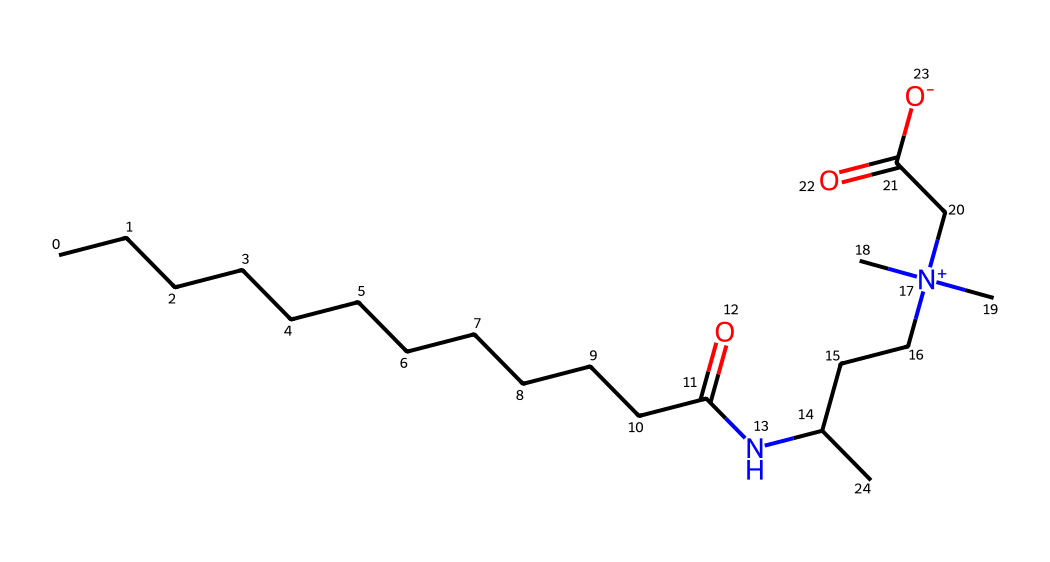What is the name of this chemical? The SMILES representation identifies this chemical as cocamidopropyl betaine, which is a common surfactant.
Answer: cocamidopropyl betaine How many carbon atoms are present in this structure? By analyzing the SMILES, there are twelve carbon atoms in the long hydrocarbon chain (CCCCCCCCCCCC) and additional ones in the propionic acid and nitrogen-containing parts. When summed, it totals to 17 carbon atoms.
Answer: 17 What type of functional group is represented by "NC" in this structure? The "NC" part indicates an amine functional group due to the presence of a nitrogen atom bonded to a carbon atom.
Answer: amine How many nitrogen atoms are in the molecule? The SMILES representation contains one "N" which indicates there is one nitrogen atom in the entire chemical structure.
Answer: 1 What does the "+", found in "[N+]" signify in the structure? The "+" symbol denotes that the nitrogen atom carries a positive charge, indicating it is a quaternary ammonium compound which is characteristic of certain surfactants.
Answer: positive charge What is the significance of the "CC(=O)[O-]" part of the molecule? This portion represents a carboxylate functional group, specifically a negatively charged carboxylic acid, contributing to the surfactant's amphiphilic properties, important for reducing surface tension.
Answer: carboxylate 